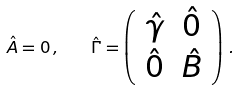Convert formula to latex. <formula><loc_0><loc_0><loc_500><loc_500>\hat { A } = 0 \, , \quad \hat { \Gamma } = \left ( \begin{array} { c c } \hat { \gamma } & \hat { 0 } \\ \hat { 0 } & \hat { B } \\ \end{array} \right ) \, .</formula> 